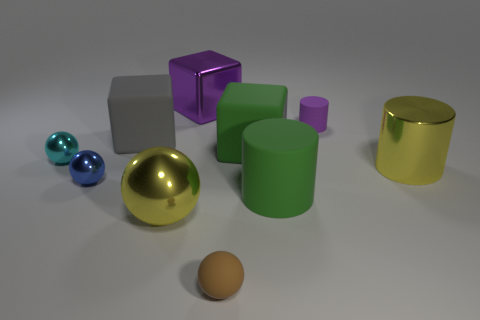The large shiny object that is the same shape as the tiny cyan metallic thing is what color?
Offer a very short reply. Yellow. Is there any other thing that is the same shape as the big purple shiny thing?
Your answer should be very brief. Yes. There is a block that is made of the same material as the cyan thing; what color is it?
Keep it short and to the point. Purple. There is a big metal block that is to the right of the big yellow shiny object that is left of the metallic cylinder; is there a green cube behind it?
Ensure brevity in your answer.  No. Are there fewer blocks in front of the large yellow sphere than big yellow metallic balls that are behind the small blue shiny object?
Your response must be concise. No. What number of small things have the same material as the yellow ball?
Ensure brevity in your answer.  2. There is a matte sphere; does it have the same size as the blue object behind the yellow sphere?
Your response must be concise. Yes. There is a thing that is the same color as the large sphere; what material is it?
Keep it short and to the point. Metal. There is a brown rubber sphere in front of the rubber thing behind the big gray rubber cube on the right side of the small blue ball; how big is it?
Your answer should be very brief. Small. Are there more tiny cyan things that are in front of the tiny blue thing than tiny cyan balls behind the gray rubber block?
Your answer should be compact. No. 